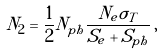Convert formula to latex. <formula><loc_0><loc_0><loc_500><loc_500>N _ { 2 } = \frac { 1 } { 2 } N _ { p h } \frac { N _ { e } \sigma _ { T } } { S _ { e } + S _ { p h } } \, ,</formula> 